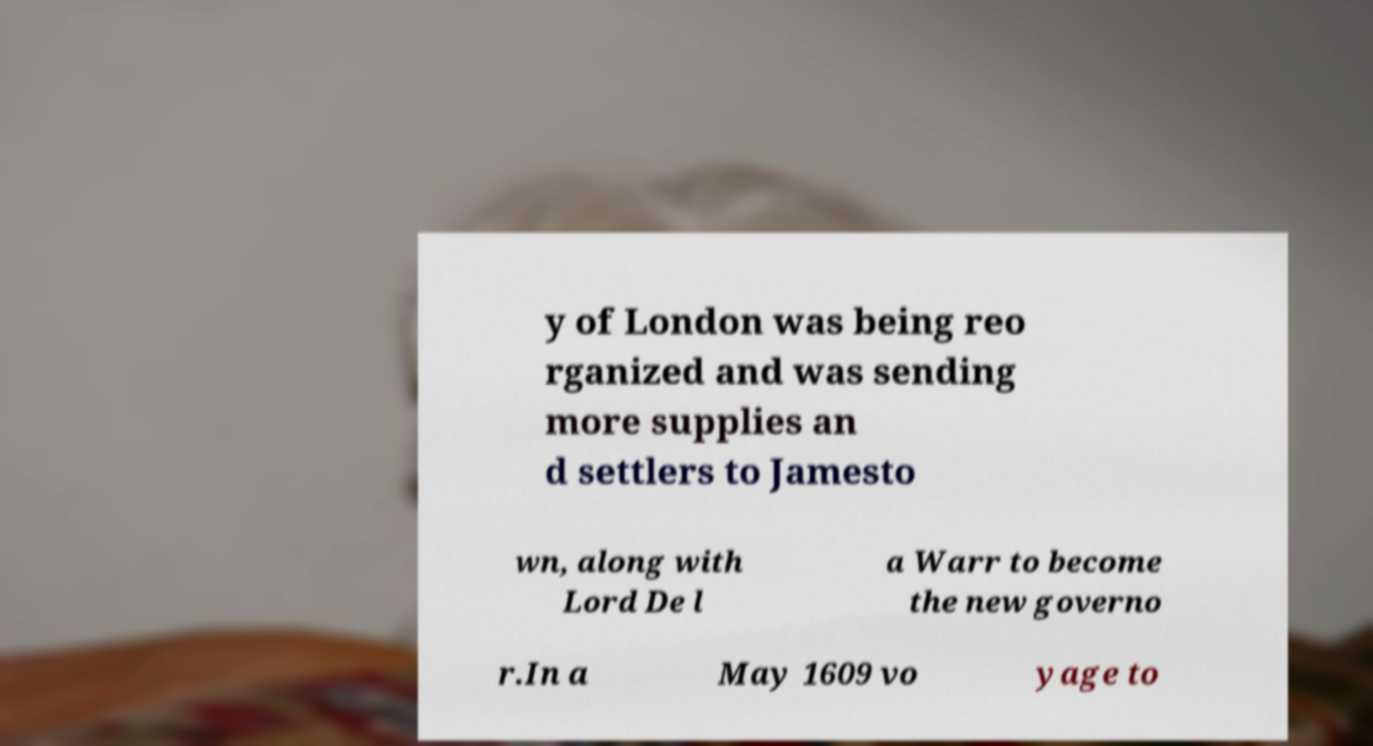Please read and relay the text visible in this image. What does it say? y of London was being reo rganized and was sending more supplies an d settlers to Jamesto wn, along with Lord De l a Warr to become the new governo r.In a May 1609 vo yage to 